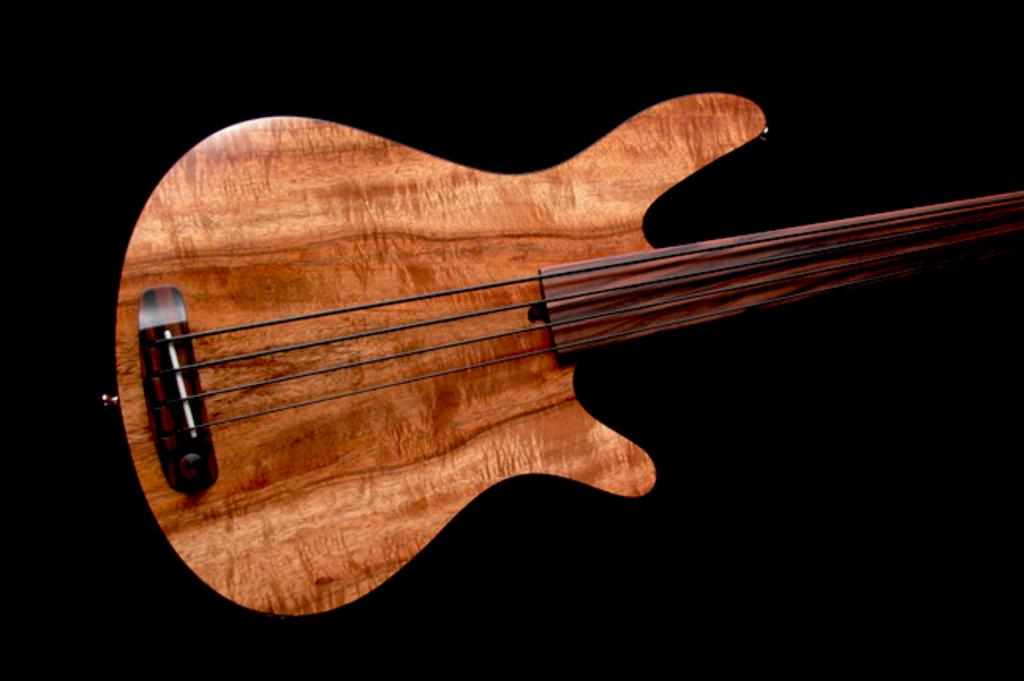What type of musical instrument is in the image? There is a wooden guitar in the image. How many strings does the guitar have? The guitar has four strings. What color is the background of the image? The background of the image is black. Can you see any icicles hanging from the guitar in the image? There are no icicles present in the image; it features a wooden guitar with four strings against a black background. 